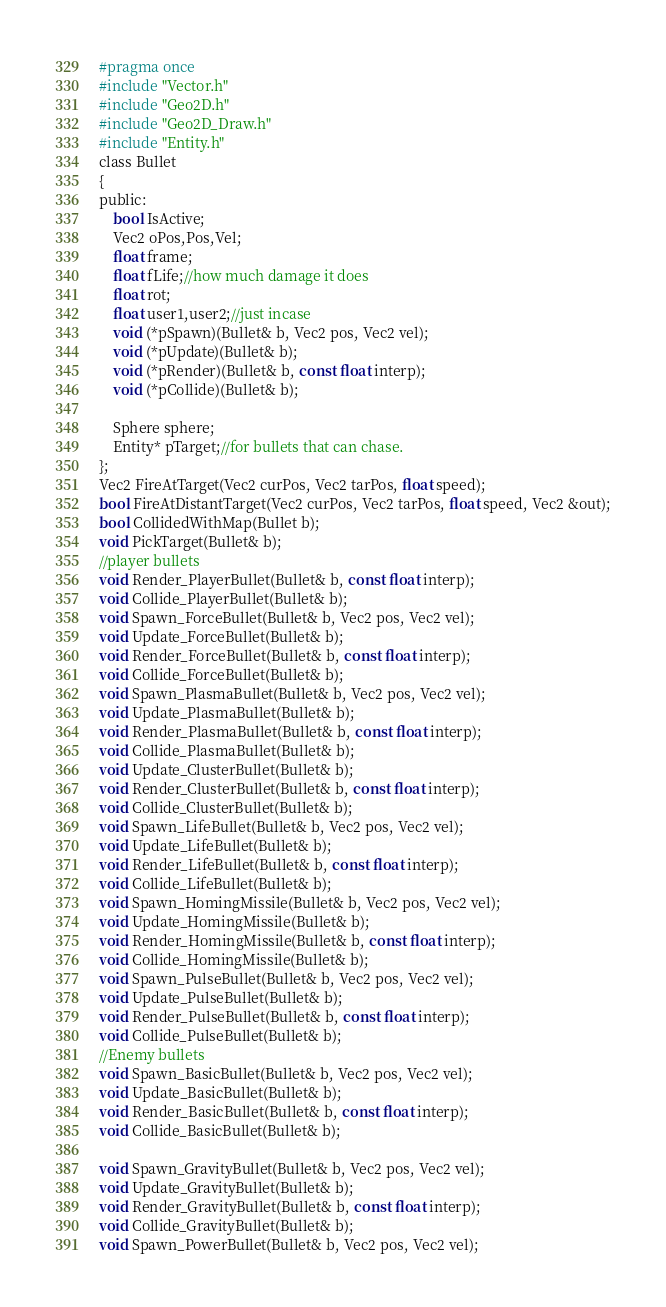<code> <loc_0><loc_0><loc_500><loc_500><_C_>#pragma once
#include "Vector.h"
#include "Geo2D.h"
#include "Geo2D_Draw.h"
#include "Entity.h"
class Bullet
{
public:
	bool IsActive;
	Vec2 oPos,Pos,Vel;
	float frame;
	float fLife;//how much damage it does
	float rot;
	float user1,user2;//just incase
	void (*pSpawn)(Bullet& b, Vec2 pos, Vec2 vel);
	void (*pUpdate)(Bullet& b);
	void (*pRender)(Bullet& b, const float interp);
	void (*pCollide)(Bullet& b);

	Sphere sphere;
	Entity* pTarget;//for bullets that can chase.
};
Vec2 FireAtTarget(Vec2 curPos, Vec2 tarPos, float speed);
bool FireAtDistantTarget(Vec2 curPos, Vec2 tarPos, float speed, Vec2 &out);
bool CollidedWithMap(Bullet b);
void PickTarget(Bullet& b);
//player bullets
void Render_PlayerBullet(Bullet& b, const float interp);
void Collide_PlayerBullet(Bullet& b);
void Spawn_ForceBullet(Bullet& b, Vec2 pos, Vec2 vel);
void Update_ForceBullet(Bullet& b);
void Render_ForceBullet(Bullet& b, const float interp);
void Collide_ForceBullet(Bullet& b);
void Spawn_PlasmaBullet(Bullet& b, Vec2 pos, Vec2 vel);
void Update_PlasmaBullet(Bullet& b);
void Render_PlasmaBullet(Bullet& b, const float interp);
void Collide_PlasmaBullet(Bullet& b);
void Update_ClusterBullet(Bullet& b);
void Render_ClusterBullet(Bullet& b, const float interp);
void Collide_ClusterBullet(Bullet& b);
void Spawn_LifeBullet(Bullet& b, Vec2 pos, Vec2 vel);
void Update_LifeBullet(Bullet& b);
void Render_LifeBullet(Bullet& b, const float interp);
void Collide_LifeBullet(Bullet& b);
void Spawn_HomingMissile(Bullet& b, Vec2 pos, Vec2 vel);
void Update_HomingMissile(Bullet& b);
void Render_HomingMissile(Bullet& b, const float interp);
void Collide_HomingMissile(Bullet& b);
void Spawn_PulseBullet(Bullet& b, Vec2 pos, Vec2 vel);
void Update_PulseBullet(Bullet& b);
void Render_PulseBullet(Bullet& b, const float interp);
void Collide_PulseBullet(Bullet& b);
//Enemy bullets
void Spawn_BasicBullet(Bullet& b, Vec2 pos, Vec2 vel);
void Update_BasicBullet(Bullet& b);
void Render_BasicBullet(Bullet& b, const float interp);
void Collide_BasicBullet(Bullet& b);

void Spawn_GravityBullet(Bullet& b, Vec2 pos, Vec2 vel);
void Update_GravityBullet(Bullet& b);
void Render_GravityBullet(Bullet& b, const float interp);
void Collide_GravityBullet(Bullet& b);
void Spawn_PowerBullet(Bullet& b, Vec2 pos, Vec2 vel);</code> 